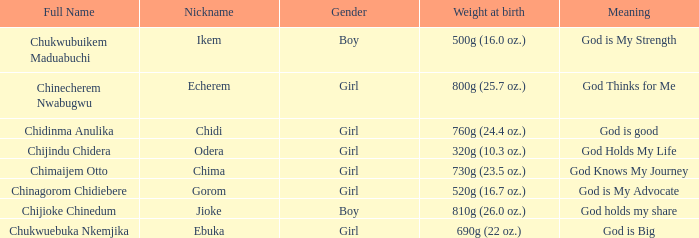What is the nickname of the boy who weighed 810g (26.0 oz.) at birth? Jioke. 